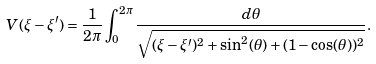Convert formula to latex. <formula><loc_0><loc_0><loc_500><loc_500>V ( \xi - \xi ^ { \prime } ) = \frac { 1 } { 2 \pi } \int _ { 0 } ^ { 2 \pi } \frac { d \theta } { \sqrt { ( \xi - \xi ^ { \prime } ) ^ { 2 } + \sin ^ { 2 } ( \theta ) + ( 1 - \cos ( \theta ) ) ^ { 2 } } } .</formula> 